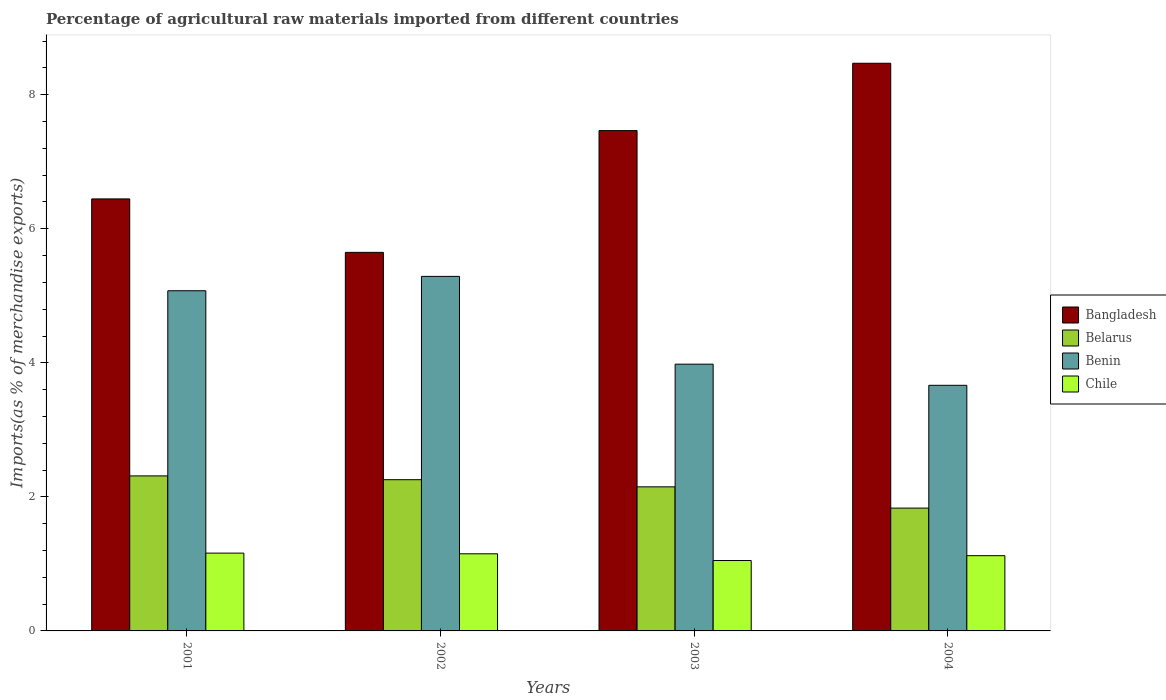How many different coloured bars are there?
Your response must be concise. 4. Are the number of bars on each tick of the X-axis equal?
Offer a terse response. Yes. How many bars are there on the 1st tick from the left?
Your answer should be very brief. 4. What is the percentage of imports to different countries in Chile in 2001?
Offer a terse response. 1.16. Across all years, what is the maximum percentage of imports to different countries in Belarus?
Your answer should be very brief. 2.31. Across all years, what is the minimum percentage of imports to different countries in Bangladesh?
Provide a succinct answer. 5.65. In which year was the percentage of imports to different countries in Chile maximum?
Provide a short and direct response. 2001. What is the total percentage of imports to different countries in Belarus in the graph?
Ensure brevity in your answer.  8.55. What is the difference between the percentage of imports to different countries in Belarus in 2002 and that in 2004?
Your answer should be compact. 0.42. What is the difference between the percentage of imports to different countries in Bangladesh in 2003 and the percentage of imports to different countries in Chile in 2001?
Keep it short and to the point. 6.3. What is the average percentage of imports to different countries in Benin per year?
Offer a very short reply. 4.5. In the year 2001, what is the difference between the percentage of imports to different countries in Bangladesh and percentage of imports to different countries in Chile?
Give a very brief answer. 5.28. In how many years, is the percentage of imports to different countries in Benin greater than 4 %?
Make the answer very short. 2. What is the ratio of the percentage of imports to different countries in Benin in 2002 to that in 2004?
Make the answer very short. 1.44. Is the percentage of imports to different countries in Belarus in 2003 less than that in 2004?
Keep it short and to the point. No. What is the difference between the highest and the second highest percentage of imports to different countries in Chile?
Provide a short and direct response. 0.01. What is the difference between the highest and the lowest percentage of imports to different countries in Belarus?
Make the answer very short. 0.48. In how many years, is the percentage of imports to different countries in Benin greater than the average percentage of imports to different countries in Benin taken over all years?
Your answer should be compact. 2. What does the 3rd bar from the left in 2003 represents?
Your answer should be very brief. Benin. What does the 1st bar from the right in 2004 represents?
Provide a succinct answer. Chile. Are the values on the major ticks of Y-axis written in scientific E-notation?
Ensure brevity in your answer.  No. Does the graph contain any zero values?
Offer a terse response. No. Does the graph contain grids?
Provide a succinct answer. No. How are the legend labels stacked?
Your response must be concise. Vertical. What is the title of the graph?
Offer a terse response. Percentage of agricultural raw materials imported from different countries. What is the label or title of the X-axis?
Offer a terse response. Years. What is the label or title of the Y-axis?
Your answer should be compact. Imports(as % of merchandise exports). What is the Imports(as % of merchandise exports) in Bangladesh in 2001?
Make the answer very short. 6.45. What is the Imports(as % of merchandise exports) of Belarus in 2001?
Your answer should be very brief. 2.31. What is the Imports(as % of merchandise exports) of Benin in 2001?
Offer a terse response. 5.08. What is the Imports(as % of merchandise exports) of Chile in 2001?
Offer a terse response. 1.16. What is the Imports(as % of merchandise exports) of Bangladesh in 2002?
Make the answer very short. 5.65. What is the Imports(as % of merchandise exports) of Belarus in 2002?
Your answer should be compact. 2.26. What is the Imports(as % of merchandise exports) of Benin in 2002?
Your answer should be very brief. 5.29. What is the Imports(as % of merchandise exports) in Chile in 2002?
Ensure brevity in your answer.  1.15. What is the Imports(as % of merchandise exports) in Bangladesh in 2003?
Offer a very short reply. 7.46. What is the Imports(as % of merchandise exports) of Belarus in 2003?
Provide a short and direct response. 2.15. What is the Imports(as % of merchandise exports) of Benin in 2003?
Your response must be concise. 3.98. What is the Imports(as % of merchandise exports) of Chile in 2003?
Ensure brevity in your answer.  1.05. What is the Imports(as % of merchandise exports) of Bangladesh in 2004?
Offer a terse response. 8.47. What is the Imports(as % of merchandise exports) of Belarus in 2004?
Offer a very short reply. 1.83. What is the Imports(as % of merchandise exports) of Benin in 2004?
Your answer should be very brief. 3.66. What is the Imports(as % of merchandise exports) of Chile in 2004?
Ensure brevity in your answer.  1.12. Across all years, what is the maximum Imports(as % of merchandise exports) of Bangladesh?
Offer a terse response. 8.47. Across all years, what is the maximum Imports(as % of merchandise exports) of Belarus?
Your answer should be compact. 2.31. Across all years, what is the maximum Imports(as % of merchandise exports) in Benin?
Make the answer very short. 5.29. Across all years, what is the maximum Imports(as % of merchandise exports) in Chile?
Provide a short and direct response. 1.16. Across all years, what is the minimum Imports(as % of merchandise exports) of Bangladesh?
Provide a succinct answer. 5.65. Across all years, what is the minimum Imports(as % of merchandise exports) of Belarus?
Your response must be concise. 1.83. Across all years, what is the minimum Imports(as % of merchandise exports) of Benin?
Offer a terse response. 3.66. Across all years, what is the minimum Imports(as % of merchandise exports) of Chile?
Offer a very short reply. 1.05. What is the total Imports(as % of merchandise exports) in Bangladesh in the graph?
Your response must be concise. 28.03. What is the total Imports(as % of merchandise exports) in Belarus in the graph?
Offer a very short reply. 8.55. What is the total Imports(as % of merchandise exports) of Benin in the graph?
Ensure brevity in your answer.  18.01. What is the total Imports(as % of merchandise exports) of Chile in the graph?
Your answer should be compact. 4.48. What is the difference between the Imports(as % of merchandise exports) in Bangladesh in 2001 and that in 2002?
Your answer should be compact. 0.8. What is the difference between the Imports(as % of merchandise exports) in Belarus in 2001 and that in 2002?
Keep it short and to the point. 0.06. What is the difference between the Imports(as % of merchandise exports) of Benin in 2001 and that in 2002?
Offer a very short reply. -0.21. What is the difference between the Imports(as % of merchandise exports) of Chile in 2001 and that in 2002?
Provide a succinct answer. 0.01. What is the difference between the Imports(as % of merchandise exports) in Bangladesh in 2001 and that in 2003?
Offer a very short reply. -1.02. What is the difference between the Imports(as % of merchandise exports) in Belarus in 2001 and that in 2003?
Offer a very short reply. 0.16. What is the difference between the Imports(as % of merchandise exports) in Benin in 2001 and that in 2003?
Provide a succinct answer. 1.1. What is the difference between the Imports(as % of merchandise exports) in Chile in 2001 and that in 2003?
Make the answer very short. 0.11. What is the difference between the Imports(as % of merchandise exports) of Bangladesh in 2001 and that in 2004?
Give a very brief answer. -2.02. What is the difference between the Imports(as % of merchandise exports) of Belarus in 2001 and that in 2004?
Your answer should be compact. 0.48. What is the difference between the Imports(as % of merchandise exports) of Benin in 2001 and that in 2004?
Give a very brief answer. 1.41. What is the difference between the Imports(as % of merchandise exports) of Chile in 2001 and that in 2004?
Your answer should be compact. 0.04. What is the difference between the Imports(as % of merchandise exports) of Bangladesh in 2002 and that in 2003?
Ensure brevity in your answer.  -1.82. What is the difference between the Imports(as % of merchandise exports) in Belarus in 2002 and that in 2003?
Your answer should be very brief. 0.11. What is the difference between the Imports(as % of merchandise exports) in Benin in 2002 and that in 2003?
Provide a short and direct response. 1.31. What is the difference between the Imports(as % of merchandise exports) of Chile in 2002 and that in 2003?
Ensure brevity in your answer.  0.1. What is the difference between the Imports(as % of merchandise exports) of Bangladesh in 2002 and that in 2004?
Offer a very short reply. -2.82. What is the difference between the Imports(as % of merchandise exports) of Belarus in 2002 and that in 2004?
Offer a very short reply. 0.42. What is the difference between the Imports(as % of merchandise exports) of Benin in 2002 and that in 2004?
Keep it short and to the point. 1.62. What is the difference between the Imports(as % of merchandise exports) in Chile in 2002 and that in 2004?
Your response must be concise. 0.03. What is the difference between the Imports(as % of merchandise exports) in Bangladesh in 2003 and that in 2004?
Make the answer very short. -1. What is the difference between the Imports(as % of merchandise exports) in Belarus in 2003 and that in 2004?
Give a very brief answer. 0.32. What is the difference between the Imports(as % of merchandise exports) of Benin in 2003 and that in 2004?
Make the answer very short. 0.32. What is the difference between the Imports(as % of merchandise exports) in Chile in 2003 and that in 2004?
Make the answer very short. -0.07. What is the difference between the Imports(as % of merchandise exports) in Bangladesh in 2001 and the Imports(as % of merchandise exports) in Belarus in 2002?
Ensure brevity in your answer.  4.19. What is the difference between the Imports(as % of merchandise exports) of Bangladesh in 2001 and the Imports(as % of merchandise exports) of Benin in 2002?
Your answer should be compact. 1.16. What is the difference between the Imports(as % of merchandise exports) of Bangladesh in 2001 and the Imports(as % of merchandise exports) of Chile in 2002?
Offer a very short reply. 5.3. What is the difference between the Imports(as % of merchandise exports) in Belarus in 2001 and the Imports(as % of merchandise exports) in Benin in 2002?
Your answer should be very brief. -2.98. What is the difference between the Imports(as % of merchandise exports) of Belarus in 2001 and the Imports(as % of merchandise exports) of Chile in 2002?
Make the answer very short. 1.16. What is the difference between the Imports(as % of merchandise exports) of Benin in 2001 and the Imports(as % of merchandise exports) of Chile in 2002?
Give a very brief answer. 3.92. What is the difference between the Imports(as % of merchandise exports) of Bangladesh in 2001 and the Imports(as % of merchandise exports) of Belarus in 2003?
Make the answer very short. 4.3. What is the difference between the Imports(as % of merchandise exports) of Bangladesh in 2001 and the Imports(as % of merchandise exports) of Benin in 2003?
Offer a very short reply. 2.47. What is the difference between the Imports(as % of merchandise exports) in Bangladesh in 2001 and the Imports(as % of merchandise exports) in Chile in 2003?
Keep it short and to the point. 5.4. What is the difference between the Imports(as % of merchandise exports) of Belarus in 2001 and the Imports(as % of merchandise exports) of Benin in 2003?
Provide a succinct answer. -1.67. What is the difference between the Imports(as % of merchandise exports) in Belarus in 2001 and the Imports(as % of merchandise exports) in Chile in 2003?
Provide a short and direct response. 1.26. What is the difference between the Imports(as % of merchandise exports) of Benin in 2001 and the Imports(as % of merchandise exports) of Chile in 2003?
Your answer should be compact. 4.03. What is the difference between the Imports(as % of merchandise exports) of Bangladesh in 2001 and the Imports(as % of merchandise exports) of Belarus in 2004?
Offer a very short reply. 4.61. What is the difference between the Imports(as % of merchandise exports) in Bangladesh in 2001 and the Imports(as % of merchandise exports) in Benin in 2004?
Keep it short and to the point. 2.78. What is the difference between the Imports(as % of merchandise exports) of Bangladesh in 2001 and the Imports(as % of merchandise exports) of Chile in 2004?
Your response must be concise. 5.32. What is the difference between the Imports(as % of merchandise exports) in Belarus in 2001 and the Imports(as % of merchandise exports) in Benin in 2004?
Offer a terse response. -1.35. What is the difference between the Imports(as % of merchandise exports) of Belarus in 2001 and the Imports(as % of merchandise exports) of Chile in 2004?
Keep it short and to the point. 1.19. What is the difference between the Imports(as % of merchandise exports) of Benin in 2001 and the Imports(as % of merchandise exports) of Chile in 2004?
Ensure brevity in your answer.  3.95. What is the difference between the Imports(as % of merchandise exports) of Bangladesh in 2002 and the Imports(as % of merchandise exports) of Belarus in 2003?
Keep it short and to the point. 3.5. What is the difference between the Imports(as % of merchandise exports) of Bangladesh in 2002 and the Imports(as % of merchandise exports) of Benin in 2003?
Ensure brevity in your answer.  1.67. What is the difference between the Imports(as % of merchandise exports) of Bangladesh in 2002 and the Imports(as % of merchandise exports) of Chile in 2003?
Your response must be concise. 4.6. What is the difference between the Imports(as % of merchandise exports) in Belarus in 2002 and the Imports(as % of merchandise exports) in Benin in 2003?
Offer a terse response. -1.72. What is the difference between the Imports(as % of merchandise exports) in Belarus in 2002 and the Imports(as % of merchandise exports) in Chile in 2003?
Your response must be concise. 1.21. What is the difference between the Imports(as % of merchandise exports) of Benin in 2002 and the Imports(as % of merchandise exports) of Chile in 2003?
Offer a very short reply. 4.24. What is the difference between the Imports(as % of merchandise exports) of Bangladesh in 2002 and the Imports(as % of merchandise exports) of Belarus in 2004?
Your answer should be very brief. 3.82. What is the difference between the Imports(as % of merchandise exports) of Bangladesh in 2002 and the Imports(as % of merchandise exports) of Benin in 2004?
Make the answer very short. 1.98. What is the difference between the Imports(as % of merchandise exports) in Bangladesh in 2002 and the Imports(as % of merchandise exports) in Chile in 2004?
Make the answer very short. 4.53. What is the difference between the Imports(as % of merchandise exports) of Belarus in 2002 and the Imports(as % of merchandise exports) of Benin in 2004?
Keep it short and to the point. -1.41. What is the difference between the Imports(as % of merchandise exports) of Belarus in 2002 and the Imports(as % of merchandise exports) of Chile in 2004?
Your answer should be very brief. 1.13. What is the difference between the Imports(as % of merchandise exports) of Benin in 2002 and the Imports(as % of merchandise exports) of Chile in 2004?
Offer a very short reply. 4.17. What is the difference between the Imports(as % of merchandise exports) of Bangladesh in 2003 and the Imports(as % of merchandise exports) of Belarus in 2004?
Ensure brevity in your answer.  5.63. What is the difference between the Imports(as % of merchandise exports) of Bangladesh in 2003 and the Imports(as % of merchandise exports) of Benin in 2004?
Give a very brief answer. 3.8. What is the difference between the Imports(as % of merchandise exports) in Bangladesh in 2003 and the Imports(as % of merchandise exports) in Chile in 2004?
Provide a succinct answer. 6.34. What is the difference between the Imports(as % of merchandise exports) in Belarus in 2003 and the Imports(as % of merchandise exports) in Benin in 2004?
Provide a short and direct response. -1.51. What is the difference between the Imports(as % of merchandise exports) of Belarus in 2003 and the Imports(as % of merchandise exports) of Chile in 2004?
Provide a short and direct response. 1.03. What is the difference between the Imports(as % of merchandise exports) in Benin in 2003 and the Imports(as % of merchandise exports) in Chile in 2004?
Provide a succinct answer. 2.86. What is the average Imports(as % of merchandise exports) in Bangladesh per year?
Provide a short and direct response. 7.01. What is the average Imports(as % of merchandise exports) of Belarus per year?
Keep it short and to the point. 2.14. What is the average Imports(as % of merchandise exports) of Benin per year?
Make the answer very short. 4.5. What is the average Imports(as % of merchandise exports) of Chile per year?
Keep it short and to the point. 1.12. In the year 2001, what is the difference between the Imports(as % of merchandise exports) of Bangladesh and Imports(as % of merchandise exports) of Belarus?
Offer a very short reply. 4.13. In the year 2001, what is the difference between the Imports(as % of merchandise exports) of Bangladesh and Imports(as % of merchandise exports) of Benin?
Provide a short and direct response. 1.37. In the year 2001, what is the difference between the Imports(as % of merchandise exports) in Bangladesh and Imports(as % of merchandise exports) in Chile?
Offer a very short reply. 5.28. In the year 2001, what is the difference between the Imports(as % of merchandise exports) of Belarus and Imports(as % of merchandise exports) of Benin?
Ensure brevity in your answer.  -2.76. In the year 2001, what is the difference between the Imports(as % of merchandise exports) of Belarus and Imports(as % of merchandise exports) of Chile?
Provide a short and direct response. 1.15. In the year 2001, what is the difference between the Imports(as % of merchandise exports) in Benin and Imports(as % of merchandise exports) in Chile?
Make the answer very short. 3.91. In the year 2002, what is the difference between the Imports(as % of merchandise exports) in Bangladesh and Imports(as % of merchandise exports) in Belarus?
Keep it short and to the point. 3.39. In the year 2002, what is the difference between the Imports(as % of merchandise exports) of Bangladesh and Imports(as % of merchandise exports) of Benin?
Offer a very short reply. 0.36. In the year 2002, what is the difference between the Imports(as % of merchandise exports) in Bangladesh and Imports(as % of merchandise exports) in Chile?
Offer a very short reply. 4.5. In the year 2002, what is the difference between the Imports(as % of merchandise exports) of Belarus and Imports(as % of merchandise exports) of Benin?
Give a very brief answer. -3.03. In the year 2002, what is the difference between the Imports(as % of merchandise exports) of Belarus and Imports(as % of merchandise exports) of Chile?
Keep it short and to the point. 1.11. In the year 2002, what is the difference between the Imports(as % of merchandise exports) in Benin and Imports(as % of merchandise exports) in Chile?
Your answer should be compact. 4.14. In the year 2003, what is the difference between the Imports(as % of merchandise exports) in Bangladesh and Imports(as % of merchandise exports) in Belarus?
Offer a very short reply. 5.32. In the year 2003, what is the difference between the Imports(as % of merchandise exports) in Bangladesh and Imports(as % of merchandise exports) in Benin?
Make the answer very short. 3.48. In the year 2003, what is the difference between the Imports(as % of merchandise exports) of Bangladesh and Imports(as % of merchandise exports) of Chile?
Make the answer very short. 6.41. In the year 2003, what is the difference between the Imports(as % of merchandise exports) of Belarus and Imports(as % of merchandise exports) of Benin?
Keep it short and to the point. -1.83. In the year 2003, what is the difference between the Imports(as % of merchandise exports) of Belarus and Imports(as % of merchandise exports) of Chile?
Your response must be concise. 1.1. In the year 2003, what is the difference between the Imports(as % of merchandise exports) of Benin and Imports(as % of merchandise exports) of Chile?
Keep it short and to the point. 2.93. In the year 2004, what is the difference between the Imports(as % of merchandise exports) in Bangladesh and Imports(as % of merchandise exports) in Belarus?
Make the answer very short. 6.64. In the year 2004, what is the difference between the Imports(as % of merchandise exports) of Bangladesh and Imports(as % of merchandise exports) of Benin?
Provide a succinct answer. 4.8. In the year 2004, what is the difference between the Imports(as % of merchandise exports) in Bangladesh and Imports(as % of merchandise exports) in Chile?
Give a very brief answer. 7.35. In the year 2004, what is the difference between the Imports(as % of merchandise exports) in Belarus and Imports(as % of merchandise exports) in Benin?
Your answer should be very brief. -1.83. In the year 2004, what is the difference between the Imports(as % of merchandise exports) in Belarus and Imports(as % of merchandise exports) in Chile?
Ensure brevity in your answer.  0.71. In the year 2004, what is the difference between the Imports(as % of merchandise exports) in Benin and Imports(as % of merchandise exports) in Chile?
Offer a very short reply. 2.54. What is the ratio of the Imports(as % of merchandise exports) of Bangladesh in 2001 to that in 2002?
Your response must be concise. 1.14. What is the ratio of the Imports(as % of merchandise exports) of Belarus in 2001 to that in 2002?
Your response must be concise. 1.03. What is the ratio of the Imports(as % of merchandise exports) in Benin in 2001 to that in 2002?
Your answer should be compact. 0.96. What is the ratio of the Imports(as % of merchandise exports) of Chile in 2001 to that in 2002?
Give a very brief answer. 1.01. What is the ratio of the Imports(as % of merchandise exports) of Bangladesh in 2001 to that in 2003?
Your response must be concise. 0.86. What is the ratio of the Imports(as % of merchandise exports) of Belarus in 2001 to that in 2003?
Your answer should be very brief. 1.08. What is the ratio of the Imports(as % of merchandise exports) of Benin in 2001 to that in 2003?
Give a very brief answer. 1.28. What is the ratio of the Imports(as % of merchandise exports) of Chile in 2001 to that in 2003?
Your response must be concise. 1.11. What is the ratio of the Imports(as % of merchandise exports) in Bangladesh in 2001 to that in 2004?
Give a very brief answer. 0.76. What is the ratio of the Imports(as % of merchandise exports) of Belarus in 2001 to that in 2004?
Your response must be concise. 1.26. What is the ratio of the Imports(as % of merchandise exports) of Benin in 2001 to that in 2004?
Your answer should be compact. 1.39. What is the ratio of the Imports(as % of merchandise exports) of Chile in 2001 to that in 2004?
Provide a succinct answer. 1.03. What is the ratio of the Imports(as % of merchandise exports) of Bangladesh in 2002 to that in 2003?
Keep it short and to the point. 0.76. What is the ratio of the Imports(as % of merchandise exports) in Belarus in 2002 to that in 2003?
Your answer should be compact. 1.05. What is the ratio of the Imports(as % of merchandise exports) of Benin in 2002 to that in 2003?
Your answer should be very brief. 1.33. What is the ratio of the Imports(as % of merchandise exports) of Chile in 2002 to that in 2003?
Your answer should be very brief. 1.1. What is the ratio of the Imports(as % of merchandise exports) of Bangladesh in 2002 to that in 2004?
Give a very brief answer. 0.67. What is the ratio of the Imports(as % of merchandise exports) in Belarus in 2002 to that in 2004?
Offer a terse response. 1.23. What is the ratio of the Imports(as % of merchandise exports) of Benin in 2002 to that in 2004?
Keep it short and to the point. 1.44. What is the ratio of the Imports(as % of merchandise exports) in Chile in 2002 to that in 2004?
Ensure brevity in your answer.  1.03. What is the ratio of the Imports(as % of merchandise exports) of Bangladesh in 2003 to that in 2004?
Provide a succinct answer. 0.88. What is the ratio of the Imports(as % of merchandise exports) of Belarus in 2003 to that in 2004?
Offer a terse response. 1.17. What is the ratio of the Imports(as % of merchandise exports) in Benin in 2003 to that in 2004?
Ensure brevity in your answer.  1.09. What is the ratio of the Imports(as % of merchandise exports) in Chile in 2003 to that in 2004?
Your answer should be compact. 0.94. What is the difference between the highest and the second highest Imports(as % of merchandise exports) of Belarus?
Your answer should be very brief. 0.06. What is the difference between the highest and the second highest Imports(as % of merchandise exports) of Benin?
Provide a succinct answer. 0.21. What is the difference between the highest and the second highest Imports(as % of merchandise exports) in Chile?
Offer a terse response. 0.01. What is the difference between the highest and the lowest Imports(as % of merchandise exports) in Bangladesh?
Your answer should be very brief. 2.82. What is the difference between the highest and the lowest Imports(as % of merchandise exports) in Belarus?
Your answer should be compact. 0.48. What is the difference between the highest and the lowest Imports(as % of merchandise exports) in Benin?
Keep it short and to the point. 1.62. What is the difference between the highest and the lowest Imports(as % of merchandise exports) in Chile?
Give a very brief answer. 0.11. 